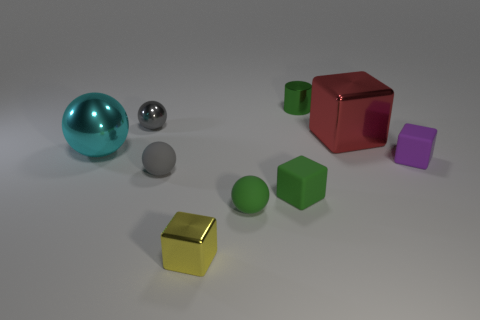Add 1 large red metallic cylinders. How many objects exist? 10 Subtract all balls. How many objects are left? 5 Add 8 cyan shiny things. How many cyan shiny things exist? 9 Subtract 0 gray cylinders. How many objects are left? 9 Subtract all small metallic spheres. Subtract all tiny cylinders. How many objects are left? 7 Add 8 large metal objects. How many large metal objects are left? 10 